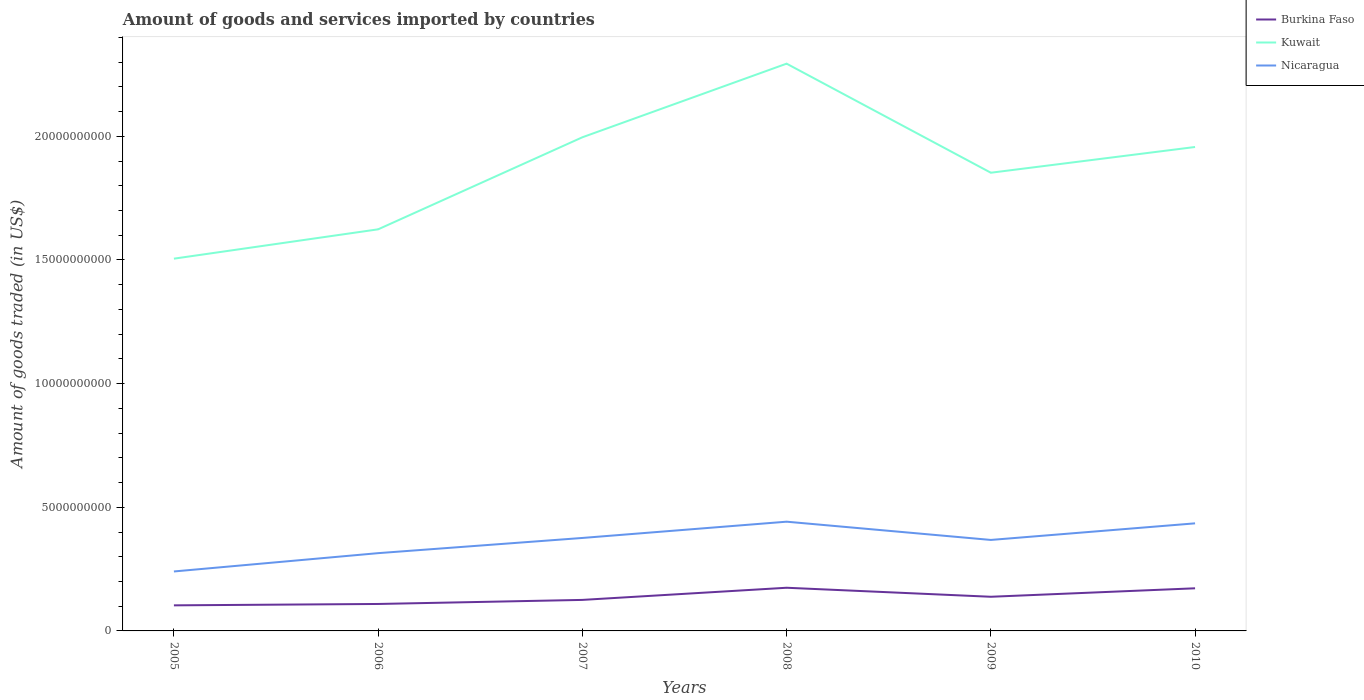How many different coloured lines are there?
Provide a succinct answer. 3. Is the number of lines equal to the number of legend labels?
Your answer should be compact. Yes. Across all years, what is the maximum total amount of goods and services imported in Nicaragua?
Give a very brief answer. 2.40e+09. In which year was the total amount of goods and services imported in Kuwait maximum?
Give a very brief answer. 2005. What is the total total amount of goods and services imported in Burkina Faso in the graph?
Keep it short and to the point. -4.69e+08. What is the difference between the highest and the second highest total amount of goods and services imported in Kuwait?
Make the answer very short. 7.89e+09. What is the difference between the highest and the lowest total amount of goods and services imported in Nicaragua?
Make the answer very short. 4. Is the total amount of goods and services imported in Kuwait strictly greater than the total amount of goods and services imported in Burkina Faso over the years?
Provide a succinct answer. No. How many years are there in the graph?
Your answer should be compact. 6. Are the values on the major ticks of Y-axis written in scientific E-notation?
Give a very brief answer. No. Does the graph contain any zero values?
Your response must be concise. No. Does the graph contain grids?
Give a very brief answer. No. Where does the legend appear in the graph?
Make the answer very short. Top right. How are the legend labels stacked?
Offer a terse response. Vertical. What is the title of the graph?
Offer a terse response. Amount of goods and services imported by countries. What is the label or title of the Y-axis?
Offer a terse response. Amount of goods traded (in US$). What is the Amount of goods traded (in US$) of Burkina Faso in 2005?
Offer a very short reply. 1.03e+09. What is the Amount of goods traded (in US$) in Kuwait in 2005?
Provide a short and direct response. 1.51e+1. What is the Amount of goods traded (in US$) of Nicaragua in 2005?
Provide a succinct answer. 2.40e+09. What is the Amount of goods traded (in US$) in Burkina Faso in 2006?
Give a very brief answer. 1.09e+09. What is the Amount of goods traded (in US$) of Kuwait in 2006?
Make the answer very short. 1.62e+1. What is the Amount of goods traded (in US$) in Nicaragua in 2006?
Ensure brevity in your answer.  3.14e+09. What is the Amount of goods traded (in US$) in Burkina Faso in 2007?
Ensure brevity in your answer.  1.25e+09. What is the Amount of goods traded (in US$) in Kuwait in 2007?
Ensure brevity in your answer.  2.00e+1. What is the Amount of goods traded (in US$) of Nicaragua in 2007?
Provide a short and direct response. 3.76e+09. What is the Amount of goods traded (in US$) in Burkina Faso in 2008?
Offer a terse response. 1.75e+09. What is the Amount of goods traded (in US$) of Kuwait in 2008?
Ensure brevity in your answer.  2.29e+1. What is the Amount of goods traded (in US$) of Nicaragua in 2008?
Give a very brief answer. 4.42e+09. What is the Amount of goods traded (in US$) in Burkina Faso in 2009?
Provide a succinct answer. 1.38e+09. What is the Amount of goods traded (in US$) in Kuwait in 2009?
Offer a very short reply. 1.85e+1. What is the Amount of goods traded (in US$) in Nicaragua in 2009?
Provide a short and direct response. 3.68e+09. What is the Amount of goods traded (in US$) in Burkina Faso in 2010?
Provide a short and direct response. 1.72e+09. What is the Amount of goods traded (in US$) of Kuwait in 2010?
Provide a succinct answer. 1.96e+1. What is the Amount of goods traded (in US$) of Nicaragua in 2010?
Provide a short and direct response. 4.35e+09. Across all years, what is the maximum Amount of goods traded (in US$) of Burkina Faso?
Your response must be concise. 1.75e+09. Across all years, what is the maximum Amount of goods traded (in US$) in Kuwait?
Your response must be concise. 2.29e+1. Across all years, what is the maximum Amount of goods traded (in US$) of Nicaragua?
Make the answer very short. 4.42e+09. Across all years, what is the minimum Amount of goods traded (in US$) in Burkina Faso?
Your answer should be compact. 1.03e+09. Across all years, what is the minimum Amount of goods traded (in US$) of Kuwait?
Make the answer very short. 1.51e+1. Across all years, what is the minimum Amount of goods traded (in US$) in Nicaragua?
Make the answer very short. 2.40e+09. What is the total Amount of goods traded (in US$) of Burkina Faso in the graph?
Provide a succinct answer. 8.23e+09. What is the total Amount of goods traded (in US$) of Kuwait in the graph?
Keep it short and to the point. 1.12e+11. What is the total Amount of goods traded (in US$) of Nicaragua in the graph?
Provide a succinct answer. 2.18e+1. What is the difference between the Amount of goods traded (in US$) of Burkina Faso in 2005 and that in 2006?
Provide a short and direct response. -5.54e+07. What is the difference between the Amount of goods traded (in US$) of Kuwait in 2005 and that in 2006?
Your answer should be compact. -1.19e+09. What is the difference between the Amount of goods traded (in US$) in Nicaragua in 2005 and that in 2006?
Offer a terse response. -7.40e+08. What is the difference between the Amount of goods traded (in US$) in Burkina Faso in 2005 and that in 2007?
Make the answer very short. -2.20e+08. What is the difference between the Amount of goods traded (in US$) of Kuwait in 2005 and that in 2007?
Provide a succinct answer. -4.91e+09. What is the difference between the Amount of goods traded (in US$) of Nicaragua in 2005 and that in 2007?
Make the answer very short. -1.35e+09. What is the difference between the Amount of goods traded (in US$) in Burkina Faso in 2005 and that in 2008?
Your answer should be compact. -7.12e+08. What is the difference between the Amount of goods traded (in US$) in Kuwait in 2005 and that in 2008?
Keep it short and to the point. -7.89e+09. What is the difference between the Amount of goods traded (in US$) in Nicaragua in 2005 and that in 2008?
Provide a succinct answer. -2.01e+09. What is the difference between the Amount of goods traded (in US$) in Burkina Faso in 2005 and that in 2009?
Provide a short and direct response. -3.47e+08. What is the difference between the Amount of goods traded (in US$) of Kuwait in 2005 and that in 2009?
Your answer should be compact. -3.48e+09. What is the difference between the Amount of goods traded (in US$) in Nicaragua in 2005 and that in 2009?
Make the answer very short. -1.27e+09. What is the difference between the Amount of goods traded (in US$) in Burkina Faso in 2005 and that in 2010?
Your answer should be compact. -6.89e+08. What is the difference between the Amount of goods traded (in US$) in Kuwait in 2005 and that in 2010?
Offer a terse response. -4.52e+09. What is the difference between the Amount of goods traded (in US$) in Nicaragua in 2005 and that in 2010?
Provide a succinct answer. -1.95e+09. What is the difference between the Amount of goods traded (in US$) of Burkina Faso in 2006 and that in 2007?
Your response must be concise. -1.65e+08. What is the difference between the Amount of goods traded (in US$) in Kuwait in 2006 and that in 2007?
Your answer should be very brief. -3.72e+09. What is the difference between the Amount of goods traded (in US$) of Nicaragua in 2006 and that in 2007?
Your response must be concise. -6.14e+08. What is the difference between the Amount of goods traded (in US$) in Burkina Faso in 2006 and that in 2008?
Offer a very short reply. -6.56e+08. What is the difference between the Amount of goods traded (in US$) of Kuwait in 2006 and that in 2008?
Provide a short and direct response. -6.70e+09. What is the difference between the Amount of goods traded (in US$) in Nicaragua in 2006 and that in 2008?
Offer a very short reply. -1.27e+09. What is the difference between the Amount of goods traded (in US$) of Burkina Faso in 2006 and that in 2009?
Your answer should be compact. -2.91e+08. What is the difference between the Amount of goods traded (in US$) in Kuwait in 2006 and that in 2009?
Give a very brief answer. -2.29e+09. What is the difference between the Amount of goods traded (in US$) of Nicaragua in 2006 and that in 2009?
Your answer should be very brief. -5.34e+08. What is the difference between the Amount of goods traded (in US$) in Burkina Faso in 2006 and that in 2010?
Keep it short and to the point. -6.34e+08. What is the difference between the Amount of goods traded (in US$) of Kuwait in 2006 and that in 2010?
Offer a terse response. -3.33e+09. What is the difference between the Amount of goods traded (in US$) of Nicaragua in 2006 and that in 2010?
Provide a succinct answer. -1.21e+09. What is the difference between the Amount of goods traded (in US$) of Burkina Faso in 2007 and that in 2008?
Offer a very short reply. -4.92e+08. What is the difference between the Amount of goods traded (in US$) of Kuwait in 2007 and that in 2008?
Ensure brevity in your answer.  -2.98e+09. What is the difference between the Amount of goods traded (in US$) of Nicaragua in 2007 and that in 2008?
Keep it short and to the point. -6.58e+08. What is the difference between the Amount of goods traded (in US$) of Burkina Faso in 2007 and that in 2009?
Keep it short and to the point. -1.27e+08. What is the difference between the Amount of goods traded (in US$) of Kuwait in 2007 and that in 2009?
Your answer should be very brief. 1.43e+09. What is the difference between the Amount of goods traded (in US$) of Nicaragua in 2007 and that in 2009?
Offer a terse response. 8.02e+07. What is the difference between the Amount of goods traded (in US$) in Burkina Faso in 2007 and that in 2010?
Give a very brief answer. -4.69e+08. What is the difference between the Amount of goods traded (in US$) of Kuwait in 2007 and that in 2010?
Keep it short and to the point. 3.93e+08. What is the difference between the Amount of goods traded (in US$) of Nicaragua in 2007 and that in 2010?
Your answer should be compact. -5.91e+08. What is the difference between the Amount of goods traded (in US$) in Burkina Faso in 2008 and that in 2009?
Provide a short and direct response. 3.65e+08. What is the difference between the Amount of goods traded (in US$) in Kuwait in 2008 and that in 2009?
Your response must be concise. 4.41e+09. What is the difference between the Amount of goods traded (in US$) of Nicaragua in 2008 and that in 2009?
Keep it short and to the point. 7.38e+08. What is the difference between the Amount of goods traded (in US$) in Burkina Faso in 2008 and that in 2010?
Keep it short and to the point. 2.26e+07. What is the difference between the Amount of goods traded (in US$) of Kuwait in 2008 and that in 2010?
Offer a very short reply. 3.37e+09. What is the difference between the Amount of goods traded (in US$) in Nicaragua in 2008 and that in 2010?
Give a very brief answer. 6.71e+07. What is the difference between the Amount of goods traded (in US$) of Burkina Faso in 2009 and that in 2010?
Your answer should be compact. -3.42e+08. What is the difference between the Amount of goods traded (in US$) in Kuwait in 2009 and that in 2010?
Offer a very short reply. -1.04e+09. What is the difference between the Amount of goods traded (in US$) of Nicaragua in 2009 and that in 2010?
Ensure brevity in your answer.  -6.71e+08. What is the difference between the Amount of goods traded (in US$) of Burkina Faso in 2005 and the Amount of goods traded (in US$) of Kuwait in 2006?
Your answer should be very brief. -1.52e+1. What is the difference between the Amount of goods traded (in US$) in Burkina Faso in 2005 and the Amount of goods traded (in US$) in Nicaragua in 2006?
Ensure brevity in your answer.  -2.11e+09. What is the difference between the Amount of goods traded (in US$) of Kuwait in 2005 and the Amount of goods traded (in US$) of Nicaragua in 2006?
Offer a terse response. 1.19e+1. What is the difference between the Amount of goods traded (in US$) in Burkina Faso in 2005 and the Amount of goods traded (in US$) in Kuwait in 2007?
Offer a terse response. -1.89e+1. What is the difference between the Amount of goods traded (in US$) of Burkina Faso in 2005 and the Amount of goods traded (in US$) of Nicaragua in 2007?
Your response must be concise. -2.72e+09. What is the difference between the Amount of goods traded (in US$) of Kuwait in 2005 and the Amount of goods traded (in US$) of Nicaragua in 2007?
Ensure brevity in your answer.  1.13e+1. What is the difference between the Amount of goods traded (in US$) in Burkina Faso in 2005 and the Amount of goods traded (in US$) in Kuwait in 2008?
Give a very brief answer. -2.19e+1. What is the difference between the Amount of goods traded (in US$) in Burkina Faso in 2005 and the Amount of goods traded (in US$) in Nicaragua in 2008?
Provide a short and direct response. -3.38e+09. What is the difference between the Amount of goods traded (in US$) of Kuwait in 2005 and the Amount of goods traded (in US$) of Nicaragua in 2008?
Offer a very short reply. 1.06e+1. What is the difference between the Amount of goods traded (in US$) in Burkina Faso in 2005 and the Amount of goods traded (in US$) in Kuwait in 2009?
Give a very brief answer. -1.75e+1. What is the difference between the Amount of goods traded (in US$) in Burkina Faso in 2005 and the Amount of goods traded (in US$) in Nicaragua in 2009?
Give a very brief answer. -2.64e+09. What is the difference between the Amount of goods traded (in US$) in Kuwait in 2005 and the Amount of goods traded (in US$) in Nicaragua in 2009?
Offer a very short reply. 1.14e+1. What is the difference between the Amount of goods traded (in US$) of Burkina Faso in 2005 and the Amount of goods traded (in US$) of Kuwait in 2010?
Ensure brevity in your answer.  -1.85e+1. What is the difference between the Amount of goods traded (in US$) of Burkina Faso in 2005 and the Amount of goods traded (in US$) of Nicaragua in 2010?
Your answer should be compact. -3.32e+09. What is the difference between the Amount of goods traded (in US$) of Kuwait in 2005 and the Amount of goods traded (in US$) of Nicaragua in 2010?
Offer a very short reply. 1.07e+1. What is the difference between the Amount of goods traded (in US$) of Burkina Faso in 2006 and the Amount of goods traded (in US$) of Kuwait in 2007?
Your answer should be compact. -1.89e+1. What is the difference between the Amount of goods traded (in US$) of Burkina Faso in 2006 and the Amount of goods traded (in US$) of Nicaragua in 2007?
Your response must be concise. -2.67e+09. What is the difference between the Amount of goods traded (in US$) of Kuwait in 2006 and the Amount of goods traded (in US$) of Nicaragua in 2007?
Give a very brief answer. 1.25e+1. What is the difference between the Amount of goods traded (in US$) in Burkina Faso in 2006 and the Amount of goods traded (in US$) in Kuwait in 2008?
Offer a terse response. -2.18e+1. What is the difference between the Amount of goods traded (in US$) in Burkina Faso in 2006 and the Amount of goods traded (in US$) in Nicaragua in 2008?
Provide a succinct answer. -3.33e+09. What is the difference between the Amount of goods traded (in US$) of Kuwait in 2006 and the Amount of goods traded (in US$) of Nicaragua in 2008?
Your answer should be compact. 1.18e+1. What is the difference between the Amount of goods traded (in US$) of Burkina Faso in 2006 and the Amount of goods traded (in US$) of Kuwait in 2009?
Your answer should be compact. -1.74e+1. What is the difference between the Amount of goods traded (in US$) in Burkina Faso in 2006 and the Amount of goods traded (in US$) in Nicaragua in 2009?
Keep it short and to the point. -2.59e+09. What is the difference between the Amount of goods traded (in US$) in Kuwait in 2006 and the Amount of goods traded (in US$) in Nicaragua in 2009?
Keep it short and to the point. 1.26e+1. What is the difference between the Amount of goods traded (in US$) in Burkina Faso in 2006 and the Amount of goods traded (in US$) in Kuwait in 2010?
Ensure brevity in your answer.  -1.85e+1. What is the difference between the Amount of goods traded (in US$) in Burkina Faso in 2006 and the Amount of goods traded (in US$) in Nicaragua in 2010?
Provide a short and direct response. -3.26e+09. What is the difference between the Amount of goods traded (in US$) of Kuwait in 2006 and the Amount of goods traded (in US$) of Nicaragua in 2010?
Provide a short and direct response. 1.19e+1. What is the difference between the Amount of goods traded (in US$) of Burkina Faso in 2007 and the Amount of goods traded (in US$) of Kuwait in 2008?
Provide a succinct answer. -2.17e+1. What is the difference between the Amount of goods traded (in US$) of Burkina Faso in 2007 and the Amount of goods traded (in US$) of Nicaragua in 2008?
Ensure brevity in your answer.  -3.16e+09. What is the difference between the Amount of goods traded (in US$) of Kuwait in 2007 and the Amount of goods traded (in US$) of Nicaragua in 2008?
Your answer should be very brief. 1.55e+1. What is the difference between the Amount of goods traded (in US$) in Burkina Faso in 2007 and the Amount of goods traded (in US$) in Kuwait in 2009?
Your answer should be compact. -1.73e+1. What is the difference between the Amount of goods traded (in US$) in Burkina Faso in 2007 and the Amount of goods traded (in US$) in Nicaragua in 2009?
Keep it short and to the point. -2.42e+09. What is the difference between the Amount of goods traded (in US$) in Kuwait in 2007 and the Amount of goods traded (in US$) in Nicaragua in 2009?
Keep it short and to the point. 1.63e+1. What is the difference between the Amount of goods traded (in US$) in Burkina Faso in 2007 and the Amount of goods traded (in US$) in Kuwait in 2010?
Your answer should be compact. -1.83e+1. What is the difference between the Amount of goods traded (in US$) in Burkina Faso in 2007 and the Amount of goods traded (in US$) in Nicaragua in 2010?
Your response must be concise. -3.10e+09. What is the difference between the Amount of goods traded (in US$) of Kuwait in 2007 and the Amount of goods traded (in US$) of Nicaragua in 2010?
Your answer should be very brief. 1.56e+1. What is the difference between the Amount of goods traded (in US$) in Burkina Faso in 2008 and the Amount of goods traded (in US$) in Kuwait in 2009?
Your answer should be compact. -1.68e+1. What is the difference between the Amount of goods traded (in US$) in Burkina Faso in 2008 and the Amount of goods traded (in US$) in Nicaragua in 2009?
Offer a terse response. -1.93e+09. What is the difference between the Amount of goods traded (in US$) in Kuwait in 2008 and the Amount of goods traded (in US$) in Nicaragua in 2009?
Offer a very short reply. 1.93e+1. What is the difference between the Amount of goods traded (in US$) of Burkina Faso in 2008 and the Amount of goods traded (in US$) of Kuwait in 2010?
Offer a terse response. -1.78e+1. What is the difference between the Amount of goods traded (in US$) of Burkina Faso in 2008 and the Amount of goods traded (in US$) of Nicaragua in 2010?
Provide a short and direct response. -2.60e+09. What is the difference between the Amount of goods traded (in US$) in Kuwait in 2008 and the Amount of goods traded (in US$) in Nicaragua in 2010?
Provide a short and direct response. 1.86e+1. What is the difference between the Amount of goods traded (in US$) of Burkina Faso in 2009 and the Amount of goods traded (in US$) of Kuwait in 2010?
Make the answer very short. -1.82e+1. What is the difference between the Amount of goods traded (in US$) in Burkina Faso in 2009 and the Amount of goods traded (in US$) in Nicaragua in 2010?
Your answer should be compact. -2.97e+09. What is the difference between the Amount of goods traded (in US$) of Kuwait in 2009 and the Amount of goods traded (in US$) of Nicaragua in 2010?
Give a very brief answer. 1.42e+1. What is the average Amount of goods traded (in US$) of Burkina Faso per year?
Provide a short and direct response. 1.37e+09. What is the average Amount of goods traded (in US$) of Kuwait per year?
Your response must be concise. 1.87e+1. What is the average Amount of goods traded (in US$) in Nicaragua per year?
Offer a very short reply. 3.63e+09. In the year 2005, what is the difference between the Amount of goods traded (in US$) of Burkina Faso and Amount of goods traded (in US$) of Kuwait?
Give a very brief answer. -1.40e+1. In the year 2005, what is the difference between the Amount of goods traded (in US$) in Burkina Faso and Amount of goods traded (in US$) in Nicaragua?
Your answer should be compact. -1.37e+09. In the year 2005, what is the difference between the Amount of goods traded (in US$) in Kuwait and Amount of goods traded (in US$) in Nicaragua?
Give a very brief answer. 1.26e+1. In the year 2006, what is the difference between the Amount of goods traded (in US$) of Burkina Faso and Amount of goods traded (in US$) of Kuwait?
Offer a terse response. -1.52e+1. In the year 2006, what is the difference between the Amount of goods traded (in US$) in Burkina Faso and Amount of goods traded (in US$) in Nicaragua?
Provide a succinct answer. -2.06e+09. In the year 2006, what is the difference between the Amount of goods traded (in US$) of Kuwait and Amount of goods traded (in US$) of Nicaragua?
Give a very brief answer. 1.31e+1. In the year 2007, what is the difference between the Amount of goods traded (in US$) of Burkina Faso and Amount of goods traded (in US$) of Kuwait?
Provide a succinct answer. -1.87e+1. In the year 2007, what is the difference between the Amount of goods traded (in US$) in Burkina Faso and Amount of goods traded (in US$) in Nicaragua?
Your answer should be compact. -2.50e+09. In the year 2007, what is the difference between the Amount of goods traded (in US$) in Kuwait and Amount of goods traded (in US$) in Nicaragua?
Offer a terse response. 1.62e+1. In the year 2008, what is the difference between the Amount of goods traded (in US$) of Burkina Faso and Amount of goods traded (in US$) of Kuwait?
Give a very brief answer. -2.12e+1. In the year 2008, what is the difference between the Amount of goods traded (in US$) of Burkina Faso and Amount of goods traded (in US$) of Nicaragua?
Your answer should be compact. -2.67e+09. In the year 2008, what is the difference between the Amount of goods traded (in US$) in Kuwait and Amount of goods traded (in US$) in Nicaragua?
Offer a very short reply. 1.85e+1. In the year 2009, what is the difference between the Amount of goods traded (in US$) of Burkina Faso and Amount of goods traded (in US$) of Kuwait?
Your answer should be very brief. -1.71e+1. In the year 2009, what is the difference between the Amount of goods traded (in US$) in Burkina Faso and Amount of goods traded (in US$) in Nicaragua?
Your answer should be compact. -2.30e+09. In the year 2009, what is the difference between the Amount of goods traded (in US$) in Kuwait and Amount of goods traded (in US$) in Nicaragua?
Keep it short and to the point. 1.48e+1. In the year 2010, what is the difference between the Amount of goods traded (in US$) of Burkina Faso and Amount of goods traded (in US$) of Kuwait?
Offer a very short reply. -1.78e+1. In the year 2010, what is the difference between the Amount of goods traded (in US$) in Burkina Faso and Amount of goods traded (in US$) in Nicaragua?
Give a very brief answer. -2.63e+09. In the year 2010, what is the difference between the Amount of goods traded (in US$) of Kuwait and Amount of goods traded (in US$) of Nicaragua?
Keep it short and to the point. 1.52e+1. What is the ratio of the Amount of goods traded (in US$) of Burkina Faso in 2005 to that in 2006?
Give a very brief answer. 0.95. What is the ratio of the Amount of goods traded (in US$) of Kuwait in 2005 to that in 2006?
Give a very brief answer. 0.93. What is the ratio of the Amount of goods traded (in US$) of Nicaragua in 2005 to that in 2006?
Your response must be concise. 0.76. What is the ratio of the Amount of goods traded (in US$) in Burkina Faso in 2005 to that in 2007?
Your answer should be compact. 0.82. What is the ratio of the Amount of goods traded (in US$) in Kuwait in 2005 to that in 2007?
Keep it short and to the point. 0.75. What is the ratio of the Amount of goods traded (in US$) of Nicaragua in 2005 to that in 2007?
Your response must be concise. 0.64. What is the ratio of the Amount of goods traded (in US$) in Burkina Faso in 2005 to that in 2008?
Make the answer very short. 0.59. What is the ratio of the Amount of goods traded (in US$) in Kuwait in 2005 to that in 2008?
Provide a short and direct response. 0.66. What is the ratio of the Amount of goods traded (in US$) in Nicaragua in 2005 to that in 2008?
Your response must be concise. 0.54. What is the ratio of the Amount of goods traded (in US$) of Burkina Faso in 2005 to that in 2009?
Keep it short and to the point. 0.75. What is the ratio of the Amount of goods traded (in US$) in Kuwait in 2005 to that in 2009?
Offer a terse response. 0.81. What is the ratio of the Amount of goods traded (in US$) of Nicaragua in 2005 to that in 2009?
Keep it short and to the point. 0.65. What is the ratio of the Amount of goods traded (in US$) in Burkina Faso in 2005 to that in 2010?
Ensure brevity in your answer.  0.6. What is the ratio of the Amount of goods traded (in US$) in Kuwait in 2005 to that in 2010?
Your answer should be compact. 0.77. What is the ratio of the Amount of goods traded (in US$) in Nicaragua in 2005 to that in 2010?
Make the answer very short. 0.55. What is the ratio of the Amount of goods traded (in US$) of Burkina Faso in 2006 to that in 2007?
Your answer should be compact. 0.87. What is the ratio of the Amount of goods traded (in US$) in Kuwait in 2006 to that in 2007?
Offer a terse response. 0.81. What is the ratio of the Amount of goods traded (in US$) of Nicaragua in 2006 to that in 2007?
Provide a short and direct response. 0.84. What is the ratio of the Amount of goods traded (in US$) of Burkina Faso in 2006 to that in 2008?
Make the answer very short. 0.62. What is the ratio of the Amount of goods traded (in US$) in Kuwait in 2006 to that in 2008?
Your answer should be very brief. 0.71. What is the ratio of the Amount of goods traded (in US$) of Nicaragua in 2006 to that in 2008?
Your answer should be compact. 0.71. What is the ratio of the Amount of goods traded (in US$) of Burkina Faso in 2006 to that in 2009?
Your answer should be very brief. 0.79. What is the ratio of the Amount of goods traded (in US$) of Kuwait in 2006 to that in 2009?
Offer a very short reply. 0.88. What is the ratio of the Amount of goods traded (in US$) in Nicaragua in 2006 to that in 2009?
Your response must be concise. 0.85. What is the ratio of the Amount of goods traded (in US$) in Burkina Faso in 2006 to that in 2010?
Offer a very short reply. 0.63. What is the ratio of the Amount of goods traded (in US$) of Kuwait in 2006 to that in 2010?
Give a very brief answer. 0.83. What is the ratio of the Amount of goods traded (in US$) of Nicaragua in 2006 to that in 2010?
Provide a succinct answer. 0.72. What is the ratio of the Amount of goods traded (in US$) of Burkina Faso in 2007 to that in 2008?
Offer a terse response. 0.72. What is the ratio of the Amount of goods traded (in US$) in Kuwait in 2007 to that in 2008?
Provide a short and direct response. 0.87. What is the ratio of the Amount of goods traded (in US$) in Nicaragua in 2007 to that in 2008?
Make the answer very short. 0.85. What is the ratio of the Amount of goods traded (in US$) of Burkina Faso in 2007 to that in 2009?
Give a very brief answer. 0.91. What is the ratio of the Amount of goods traded (in US$) of Kuwait in 2007 to that in 2009?
Make the answer very short. 1.08. What is the ratio of the Amount of goods traded (in US$) in Nicaragua in 2007 to that in 2009?
Give a very brief answer. 1.02. What is the ratio of the Amount of goods traded (in US$) of Burkina Faso in 2007 to that in 2010?
Give a very brief answer. 0.73. What is the ratio of the Amount of goods traded (in US$) in Kuwait in 2007 to that in 2010?
Offer a terse response. 1.02. What is the ratio of the Amount of goods traded (in US$) in Nicaragua in 2007 to that in 2010?
Offer a terse response. 0.86. What is the ratio of the Amount of goods traded (in US$) in Burkina Faso in 2008 to that in 2009?
Provide a short and direct response. 1.26. What is the ratio of the Amount of goods traded (in US$) in Kuwait in 2008 to that in 2009?
Your answer should be very brief. 1.24. What is the ratio of the Amount of goods traded (in US$) in Nicaragua in 2008 to that in 2009?
Ensure brevity in your answer.  1.2. What is the ratio of the Amount of goods traded (in US$) of Burkina Faso in 2008 to that in 2010?
Provide a short and direct response. 1.01. What is the ratio of the Amount of goods traded (in US$) of Kuwait in 2008 to that in 2010?
Ensure brevity in your answer.  1.17. What is the ratio of the Amount of goods traded (in US$) of Nicaragua in 2008 to that in 2010?
Keep it short and to the point. 1.02. What is the ratio of the Amount of goods traded (in US$) in Burkina Faso in 2009 to that in 2010?
Offer a terse response. 0.8. What is the ratio of the Amount of goods traded (in US$) in Kuwait in 2009 to that in 2010?
Offer a very short reply. 0.95. What is the ratio of the Amount of goods traded (in US$) in Nicaragua in 2009 to that in 2010?
Give a very brief answer. 0.85. What is the difference between the highest and the second highest Amount of goods traded (in US$) in Burkina Faso?
Provide a succinct answer. 2.26e+07. What is the difference between the highest and the second highest Amount of goods traded (in US$) of Kuwait?
Your answer should be very brief. 2.98e+09. What is the difference between the highest and the second highest Amount of goods traded (in US$) in Nicaragua?
Give a very brief answer. 6.71e+07. What is the difference between the highest and the lowest Amount of goods traded (in US$) of Burkina Faso?
Ensure brevity in your answer.  7.12e+08. What is the difference between the highest and the lowest Amount of goods traded (in US$) of Kuwait?
Keep it short and to the point. 7.89e+09. What is the difference between the highest and the lowest Amount of goods traded (in US$) in Nicaragua?
Provide a succinct answer. 2.01e+09. 